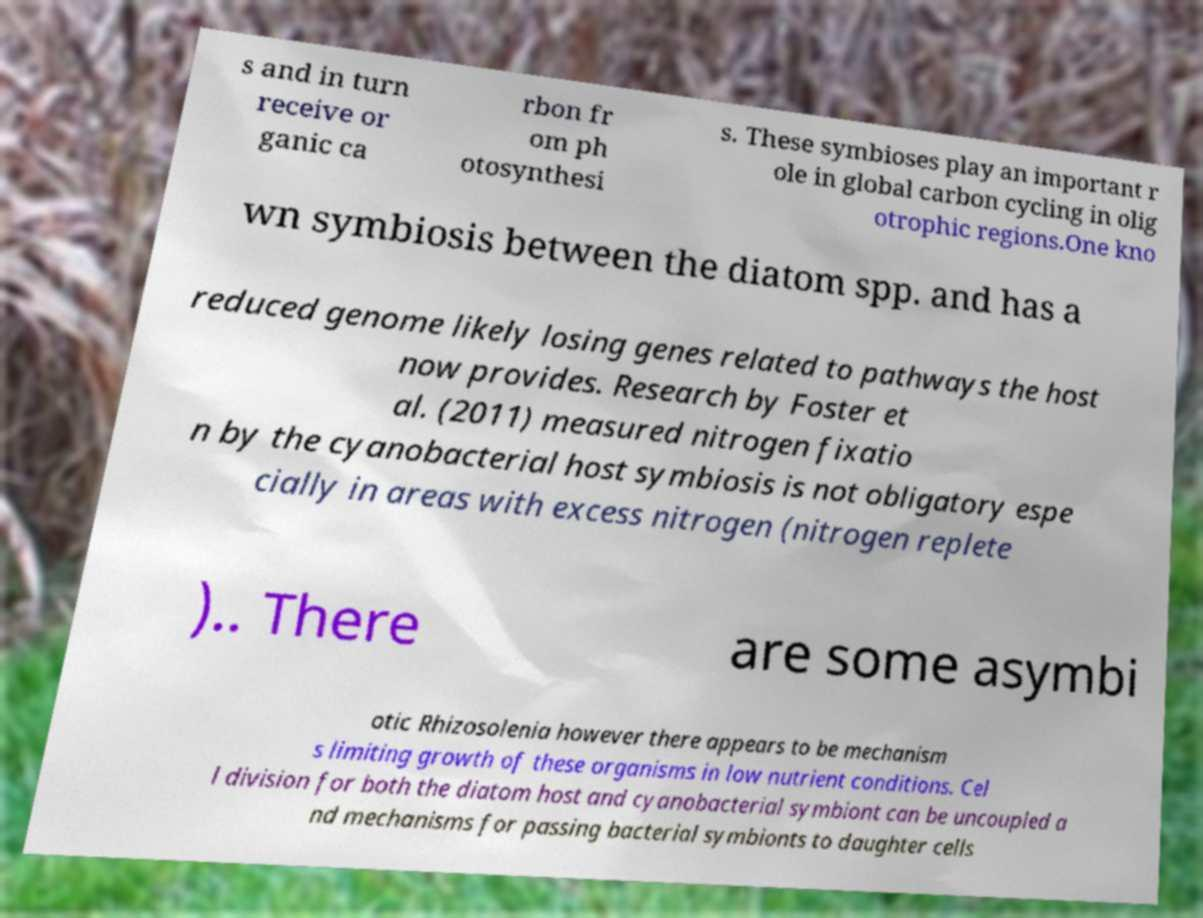Can you read and provide the text displayed in the image?This photo seems to have some interesting text. Can you extract and type it out for me? s and in turn receive or ganic ca rbon fr om ph otosynthesi s. These symbioses play an important r ole in global carbon cycling in olig otrophic regions.One kno wn symbiosis between the diatom spp. and has a reduced genome likely losing genes related to pathways the host now provides. Research by Foster et al. (2011) measured nitrogen fixatio n by the cyanobacterial host symbiosis is not obligatory espe cially in areas with excess nitrogen (nitrogen replete ).. There are some asymbi otic Rhizosolenia however there appears to be mechanism s limiting growth of these organisms in low nutrient conditions. Cel l division for both the diatom host and cyanobacterial symbiont can be uncoupled a nd mechanisms for passing bacterial symbionts to daughter cells 